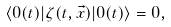Convert formula to latex. <formula><loc_0><loc_0><loc_500><loc_500>\langle 0 ( t ) | \zeta ( t , \vec { x } ) | 0 ( t ) \rangle = 0 ,</formula> 